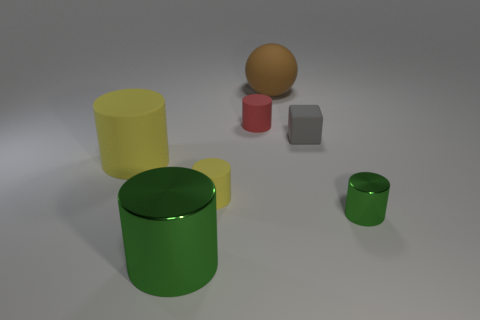Subtract all gray spheres. How many green cylinders are left? 2 Subtract all red cylinders. How many cylinders are left? 4 Subtract all tiny red rubber cylinders. How many cylinders are left? 4 Subtract 3 cylinders. How many cylinders are left? 2 Add 2 yellow things. How many objects exist? 9 Subtract all spheres. How many objects are left? 6 Subtract all gray cylinders. Subtract all brown spheres. How many cylinders are left? 5 Subtract 0 brown cylinders. How many objects are left? 7 Subtract all large spheres. Subtract all brown balls. How many objects are left? 5 Add 3 green things. How many green things are left? 5 